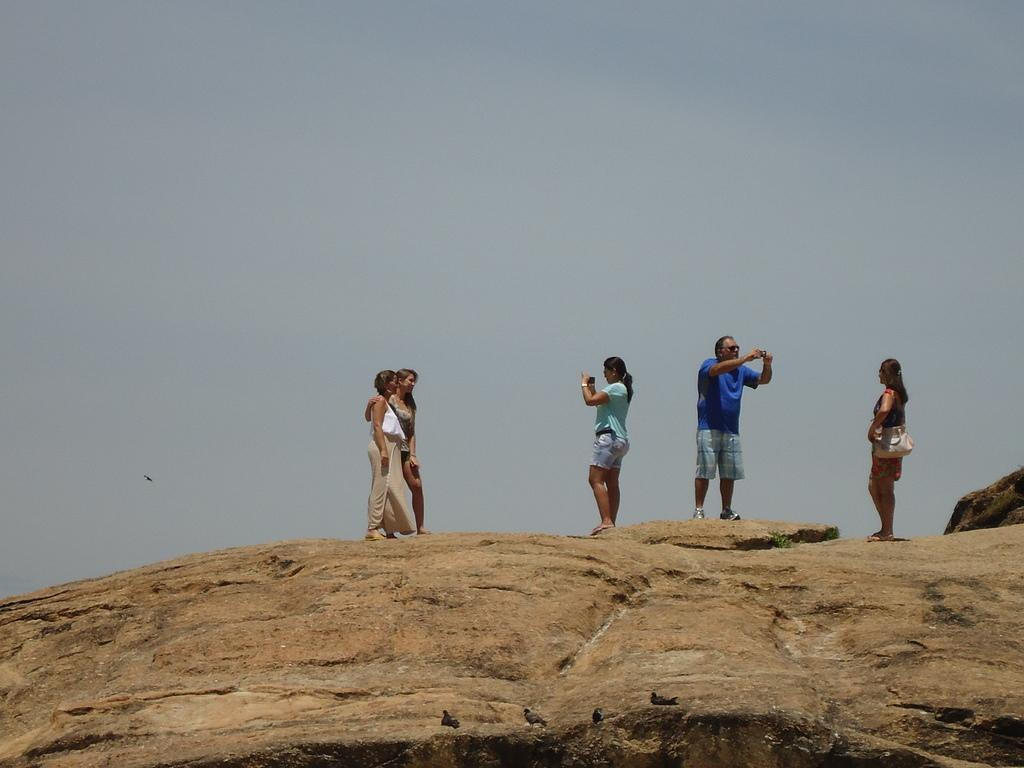What is the main object in the image? There is a rock in the image. What are the people on the rock doing? Some of the people are holding a camera, while others are holding a bag. What else can be seen in the image besides the rock and people? There are birds in the image. What is visible in the background of the image? The sky is visible in the background of the image. What type of muscle is being exercised by the people on the rock? There is no indication in the image that the people are exercising any muscles, and therefore it cannot be determined which muscle might be involved. 